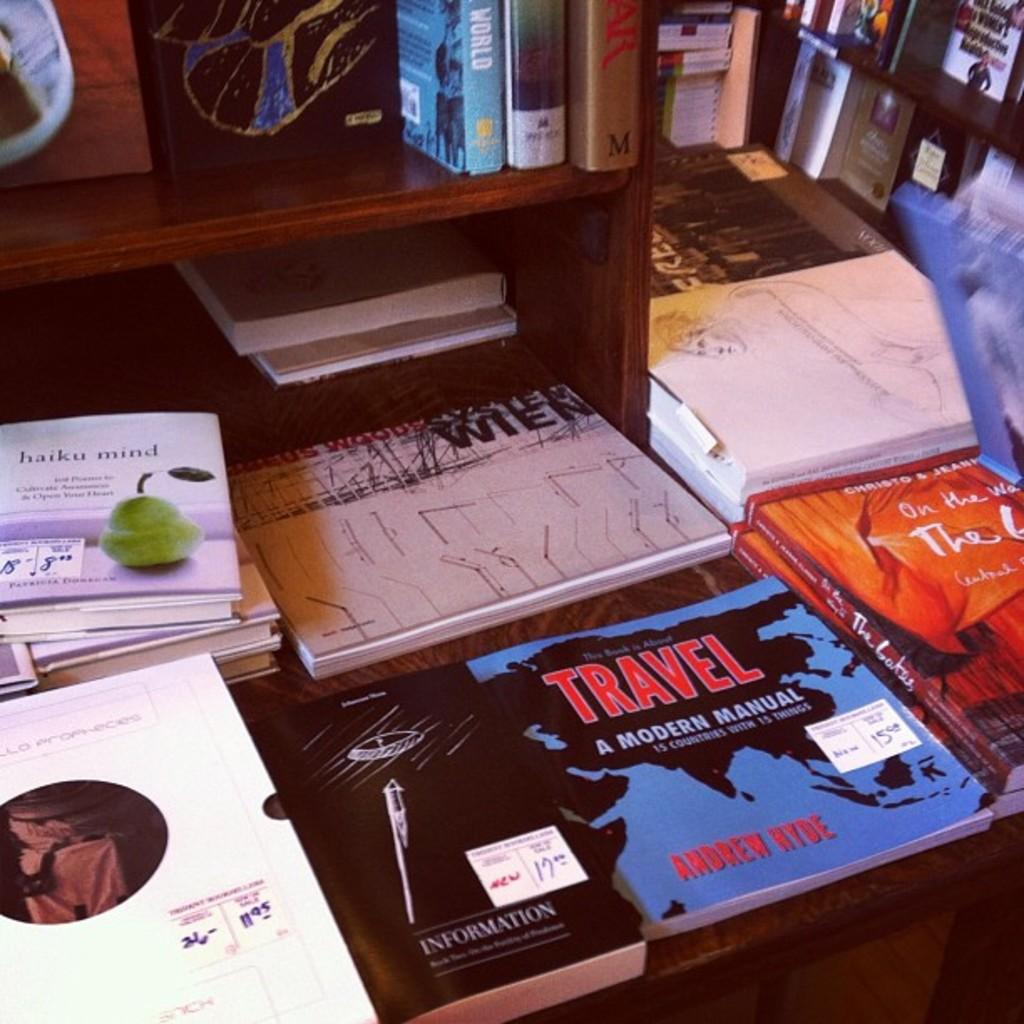<image>
Give a short and clear explanation of the subsequent image. table with a variety of books including haiku mind and travel a modern manual 